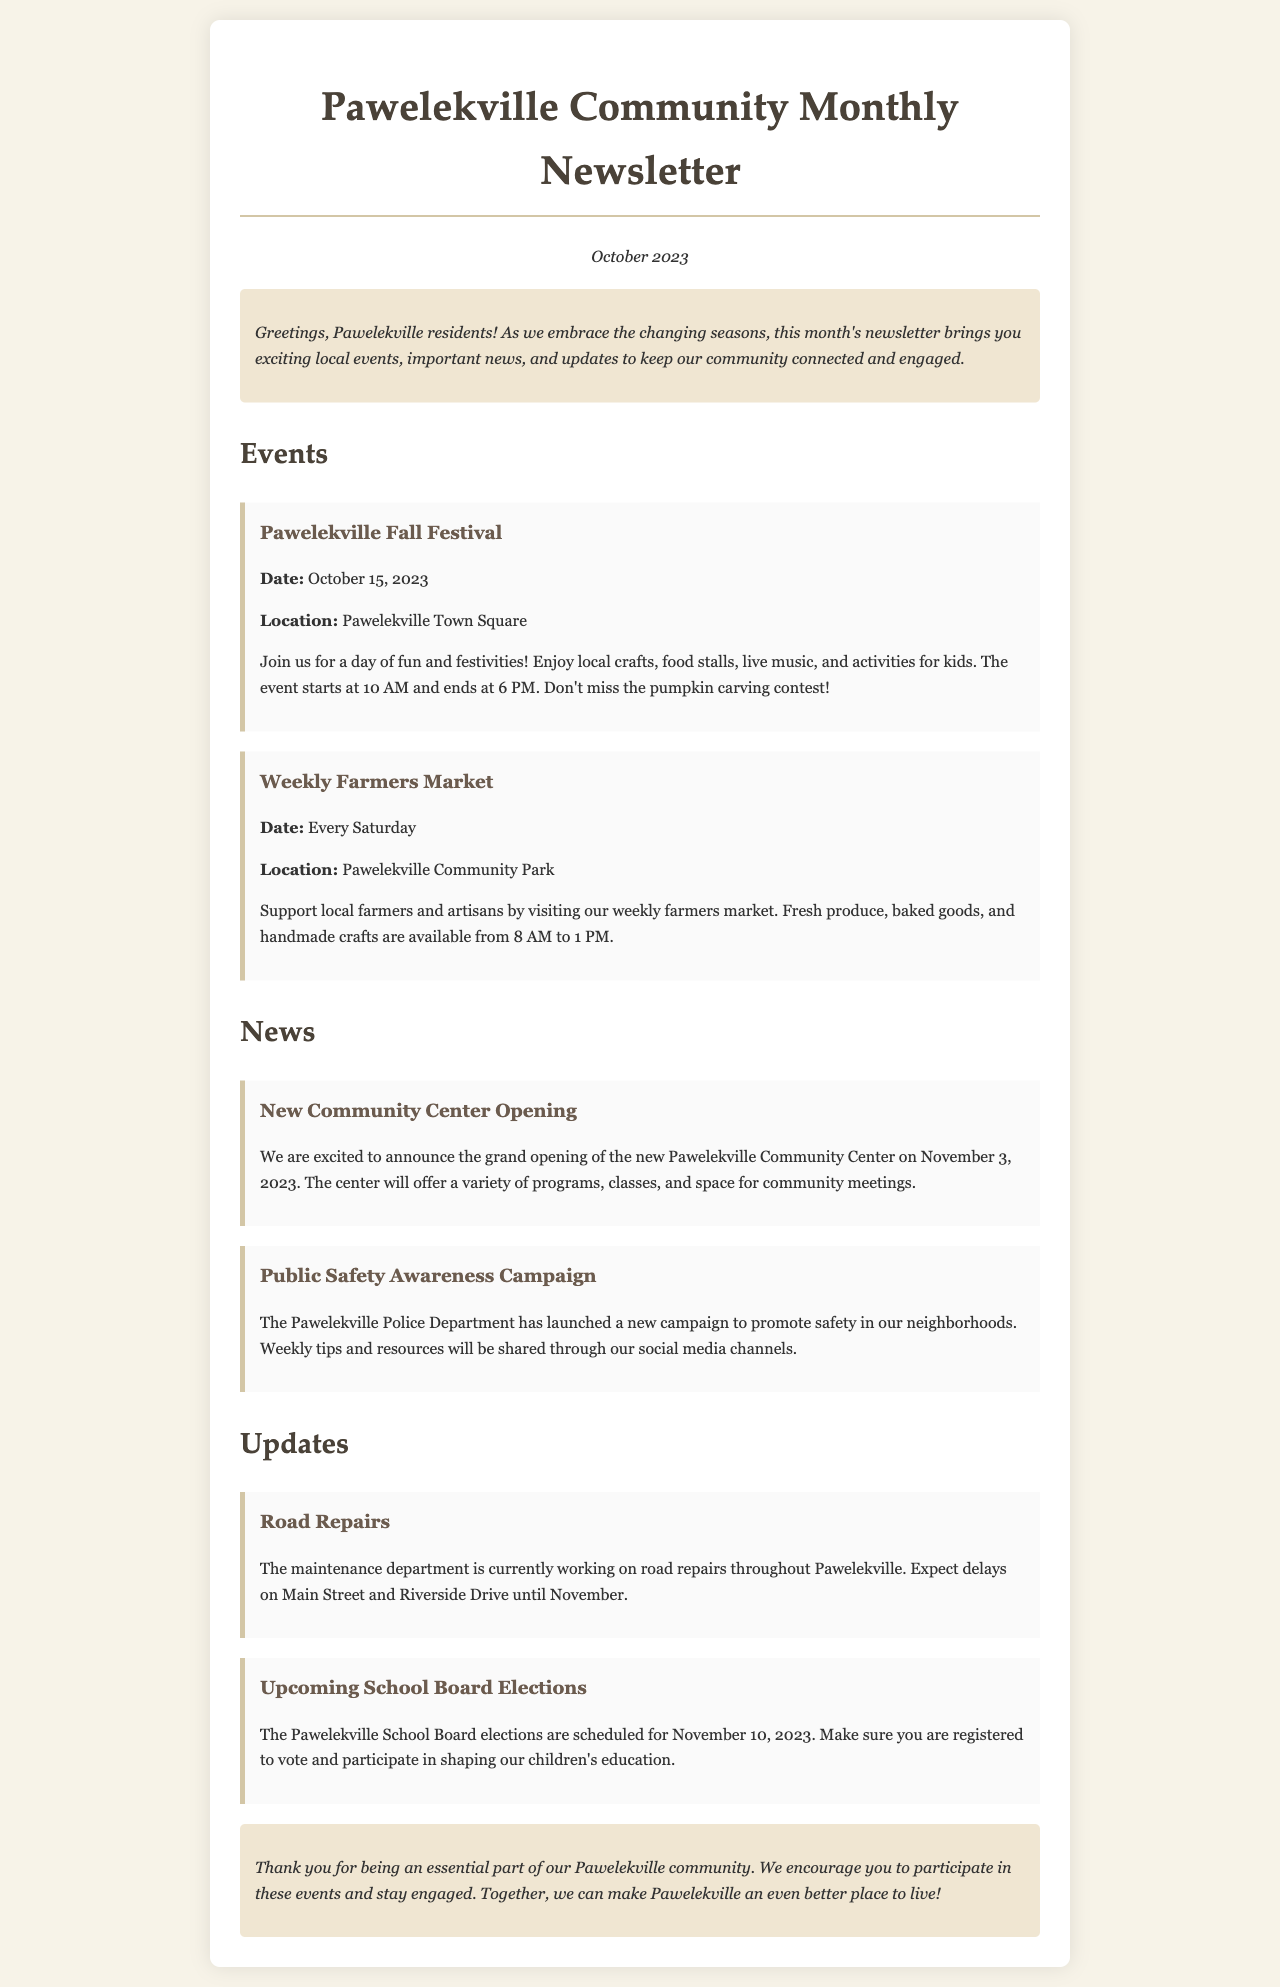What date is the Pawelekville Fall Festival? The festival is scheduled for October 15, 2023, as stated in the event section.
Answer: October 15, 2023 What is held every Saturday in Pawelekville? The document mentions the Weekly Farmers Market occurs every Saturday at the community park.
Answer: Weekly Farmers Market When is the grand opening of the new Community Center? The newsletter states that the grand opening will occur on November 3, 2023.
Answer: November 3, 2023 What is the focus of the public safety awareness campaign? The Pawelekville Police Department aims to promote safety in neighborhoods, according to the news item.
Answer: Safety What will be discussed in the upcoming School Board elections? These elections will focus on voting for members who will influence the education of children in Pawelekville.
Answer: Education What major interruption is mentioned in the updates? There are ongoing road repairs affecting Main Street and Riverside Drive, leading to delays in those areas.
Answer: Road repairs What type of events are highlighted in the monthly newsletter? The newsletter focuses on local events, important news, and community updates relevant to residents.
Answer: Community events What is the start time for the farmers market? The farmers market operates from 8 AM to 1 PM, as specified in the event details.
Answer: 8 AM What is the location for the Pawelekville Fall Festival? The event is taking place at the Pawelekville Town Square, as indicated in the details.
Answer: Pawelekville Town Square 